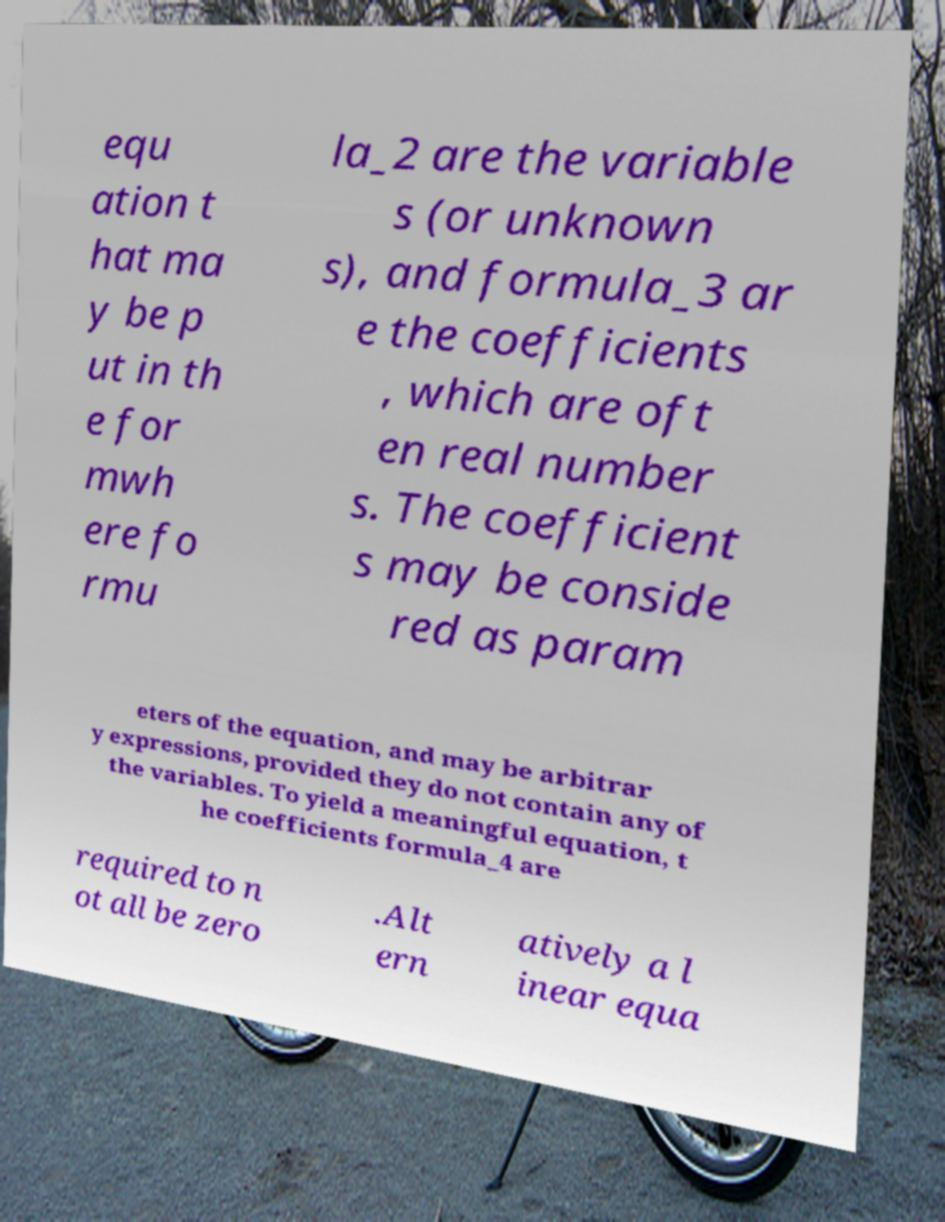Can you read and provide the text displayed in the image?This photo seems to have some interesting text. Can you extract and type it out for me? equ ation t hat ma y be p ut in th e for mwh ere fo rmu la_2 are the variable s (or unknown s), and formula_3 ar e the coefficients , which are oft en real number s. The coefficient s may be conside red as param eters of the equation, and may be arbitrar y expressions, provided they do not contain any of the variables. To yield a meaningful equation, t he coefficients formula_4 are required to n ot all be zero .Alt ern atively a l inear equa 